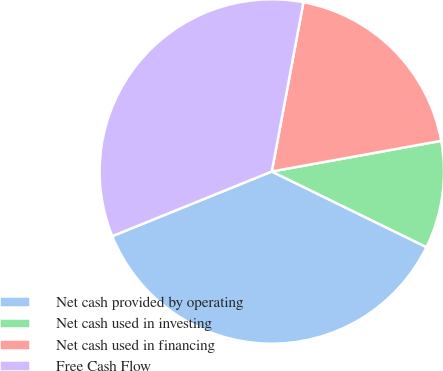<chart> <loc_0><loc_0><loc_500><loc_500><pie_chart><fcel>Net cash provided by operating<fcel>Net cash used in investing<fcel>Net cash used in financing<fcel>Free Cash Flow<nl><fcel>36.63%<fcel>10.09%<fcel>19.21%<fcel>34.07%<nl></chart> 